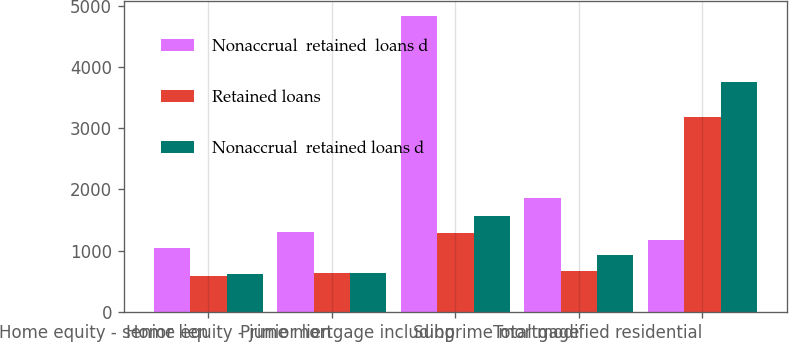Convert chart to OTSL. <chart><loc_0><loc_0><loc_500><loc_500><stacked_bar_chart><ecel><fcel>Home equity - senior lien<fcel>Home equity - junior lien<fcel>Prime mortgage including<fcel>Subprime mortgage<fcel>Total modified residential<nl><fcel>Nonaccrual  retained  loans d<fcel>1048<fcel>1310<fcel>4826<fcel>1864<fcel>1167.5<nl><fcel>Retained loans<fcel>581<fcel>639<fcel>1287<fcel>670<fcel>3177<nl><fcel>Nonaccrual  retained loans d<fcel>628<fcel>632<fcel>1559<fcel>931<fcel>3750<nl></chart> 